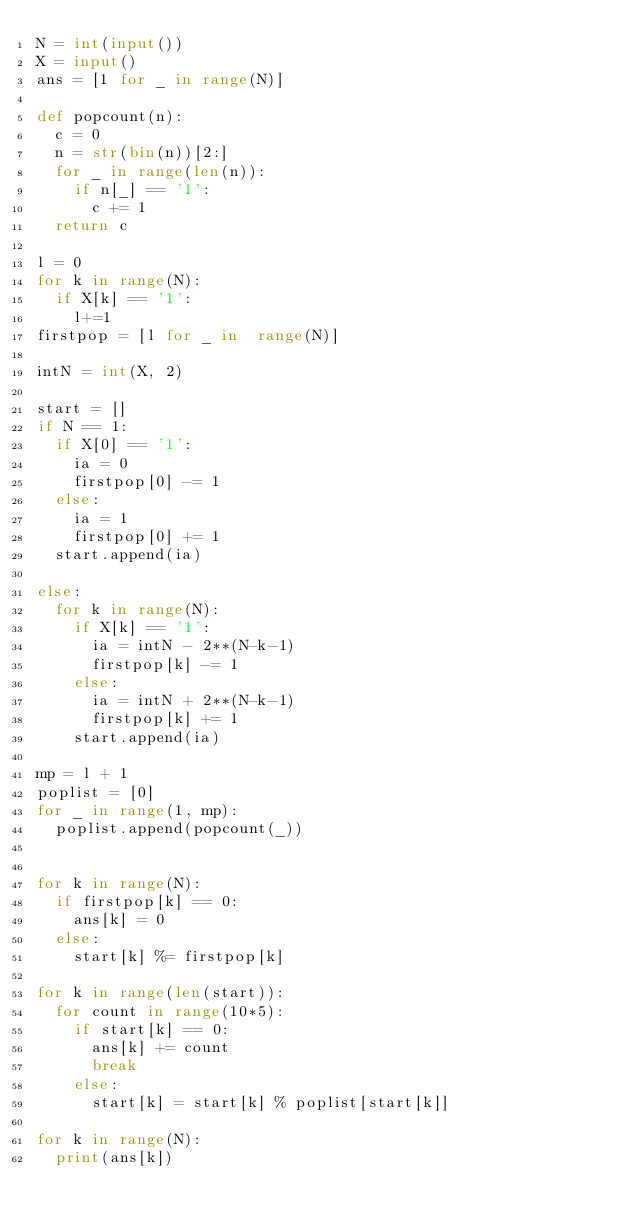<code> <loc_0><loc_0><loc_500><loc_500><_Python_>N = int(input())
X = input()
ans = [1 for _ in range(N)]

def popcount(n):
  c = 0
  n = str(bin(n))[2:]
  for _ in range(len(n)):
    if n[_] == '1':
      c += 1
  return c

l = 0
for k in range(N):
  if X[k] == '1':
    l+=1
firstpop = [l for _ in  range(N)]

intN = int(X, 2)

start = []
if N == 1:
  if X[0] == '1':
    ia = 0
    firstpop[0] -= 1
  else:
    ia = 1
    firstpop[0] += 1
  start.append(ia)

else:
  for k in range(N):
    if X[k] == '1':
      ia = intN - 2**(N-k-1)
      firstpop[k] -= 1
    else:
      ia = intN + 2**(N-k-1)
      firstpop[k] += 1
    start.append(ia)

mp = l + 1
poplist = [0]
for _ in range(1, mp):
  poplist.append(popcount(_))


for k in range(N):
  if firstpop[k] == 0:
    ans[k] = 0
  else:
    start[k] %= firstpop[k]

for k in range(len(start)):
  for count in range(10*5):
    if start[k] == 0:
      ans[k] += count
      break
    else:
      start[k] = start[k] % poplist[start[k]]

for k in range(N):
  print(ans[k])</code> 